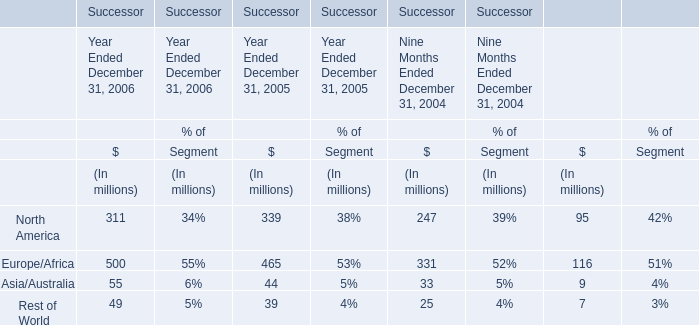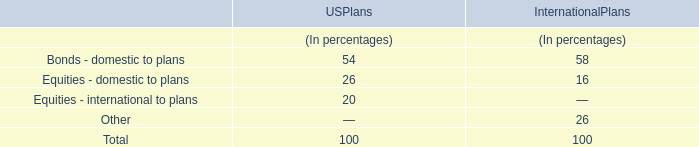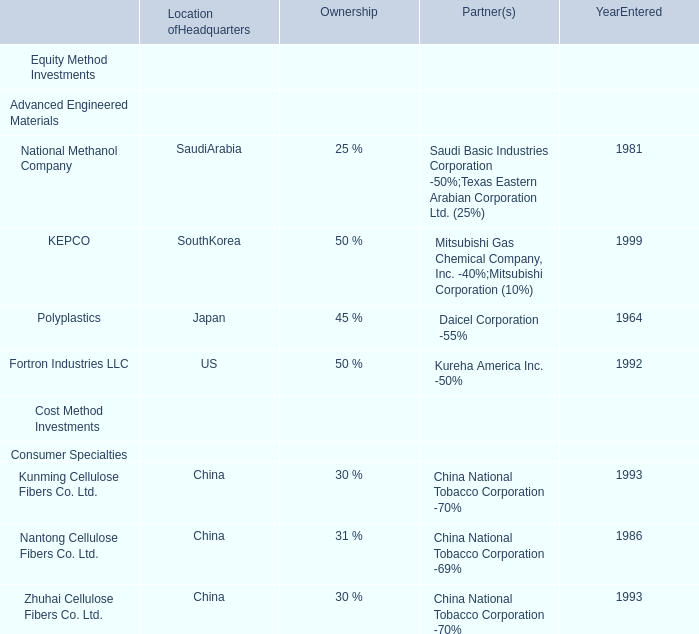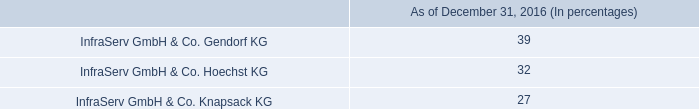what was the percentage change in the the research and development costs from 2014 to 2015 
Computations: (((119 - 86) + 86) / 2)
Answer: 59.5. 